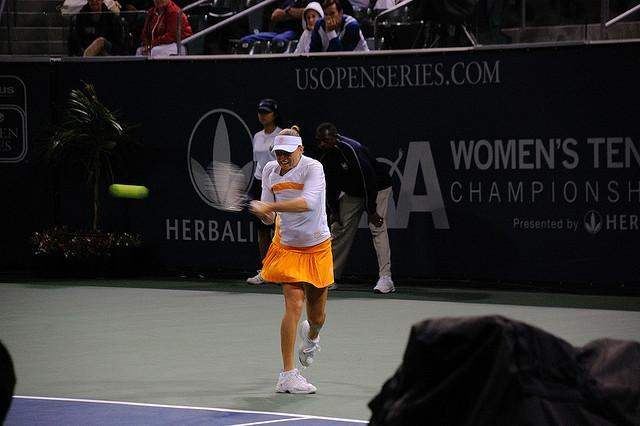Where is this tournament based? europe 